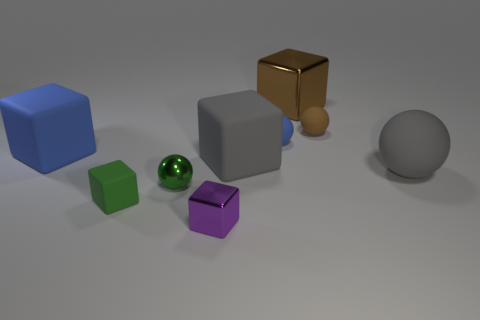The brown sphere is what size?
Make the answer very short. Small. Is the number of purple cubes behind the small purple thing greater than the number of purple shiny blocks on the left side of the small brown object?
Offer a terse response. No. There is a small purple shiny thing; are there any things on the right side of it?
Your answer should be compact. Yes. Is there a object that has the same size as the metal sphere?
Give a very brief answer. Yes. What is the color of the tiny cube that is the same material as the large sphere?
Your response must be concise. Green. What is the material of the large brown cube?
Provide a short and direct response. Metal. The tiny blue matte thing has what shape?
Ensure brevity in your answer.  Sphere. How many cubes have the same color as the small metal sphere?
Offer a very short reply. 1. What material is the large thing that is behind the blue matte thing to the left of the small sphere on the left side of the purple metal cube?
Your response must be concise. Metal. What number of brown objects are metal objects or tiny metal cubes?
Provide a short and direct response. 1. 